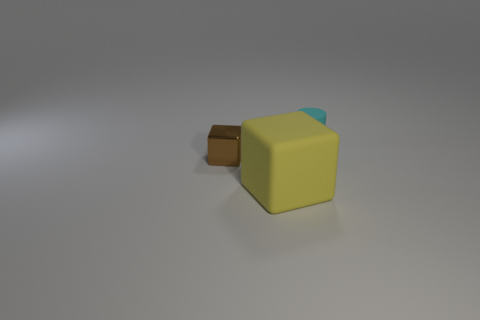How does the object's color contrast with its background? The yellow and blue colors of the object stand out against the neutral gray background, providing a clear visual separation that draws attention to the object. The contrast is not overly stark, but it is sufficient to make the object the focal point in the view. 